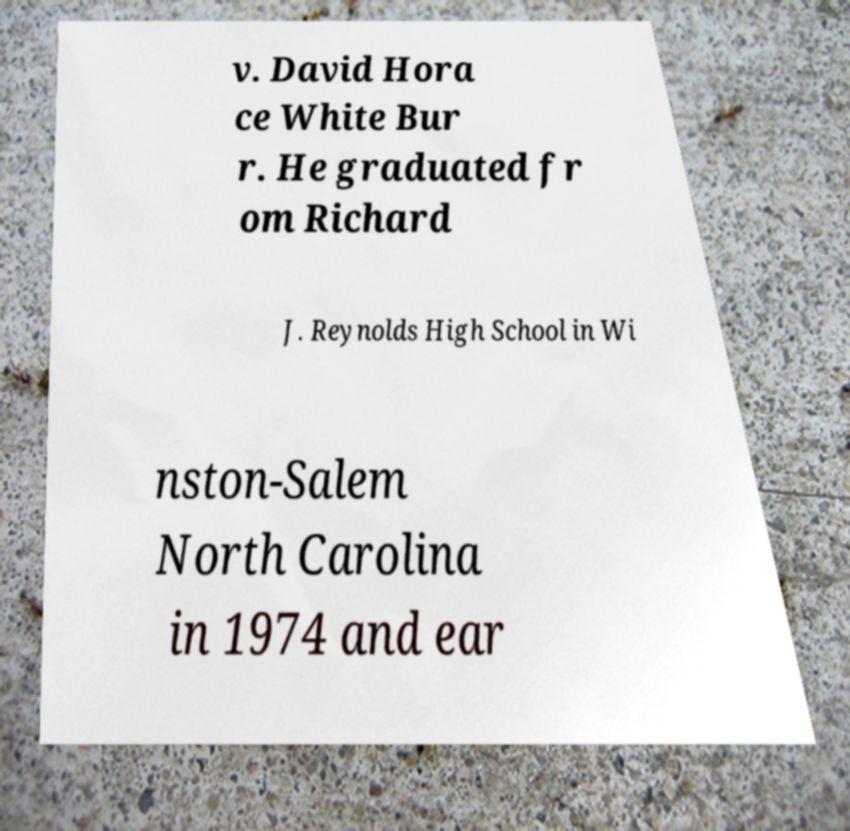I need the written content from this picture converted into text. Can you do that? v. David Hora ce White Bur r. He graduated fr om Richard J. Reynolds High School in Wi nston-Salem North Carolina in 1974 and ear 